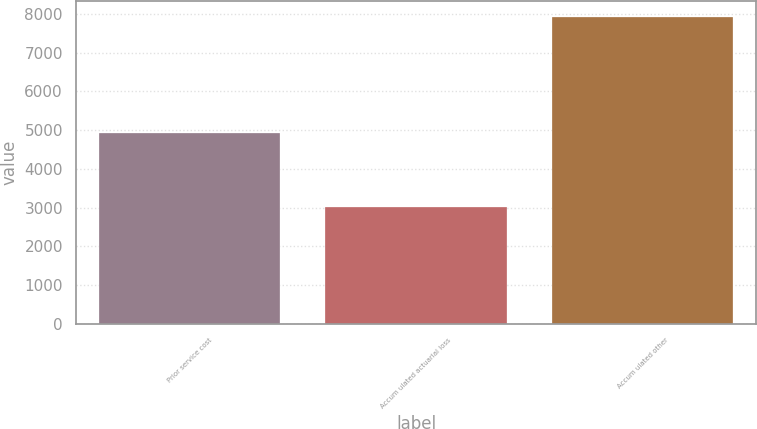Convert chart. <chart><loc_0><loc_0><loc_500><loc_500><bar_chart><fcel>Prior service cost<fcel>Accum ulated actuarial loss<fcel>Accum ulated other<nl><fcel>4915<fcel>3008<fcel>7923<nl></chart> 